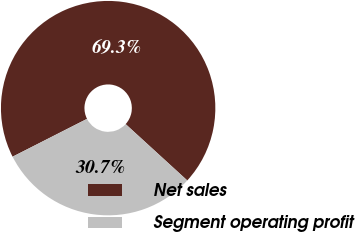Convert chart to OTSL. <chart><loc_0><loc_0><loc_500><loc_500><pie_chart><fcel>Net sales<fcel>Segment operating profit<nl><fcel>69.27%<fcel>30.73%<nl></chart> 